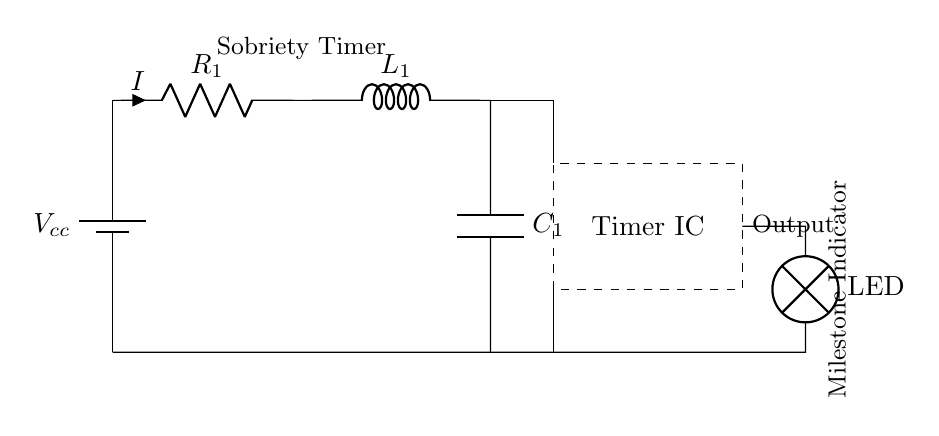What is the voltage source labeled in the circuit? The voltage source in this circuit is labeled as Vcc, which indicates the positive voltage supply connected to the circuit.
Answer: Vcc What components are connected in series? In the circuit, the resistor, inductor, and capacitor are connected in series between the voltage source and the ground. This implies that the same current flows through each component continuously.
Answer: Resistor, inductor, capacitor What is the role of the timer IC in this circuit? The timer IC is used to create timed events or intervals based on the charging and discharging behavior of the RLC components. It controls the LED output based on the timing characteristics set by the RLC elements.
Answer: Timing control How does the current flow through the circuit? The current flows from the positive side of the voltage source Vcc, through the resistor, inductor, and capacitor in series, then returns to the ground. The flow is continuous, maintaining the same current throughout these components.
Answer: From Vcc to ground What is the function of the LED in this circuit? The LED functions as an indicator that lights up when the timer IC completes its designated timing cycle, signaling a sobriety milestone being reached or achieved.
Answer: Indicator lamp What is the total impedance of this RLC circuit? The total impedance is a combination of the resistive, inductive, and capacitive impedances, represented by the formula Z = R + j(ωL - 1/ωC). It determines how much the circuit will resist the flow of current at a given frequency.
Answer: Z = R + j(ωL - 1/ωC) What is the output action of this circuit when the timer reaches the set interval? When the timer reaches the set interval, the output action is to activate the LED, indicating that a sobriety milestone has been achieved or that a specific time period has passed.
Answer: Activate LED 